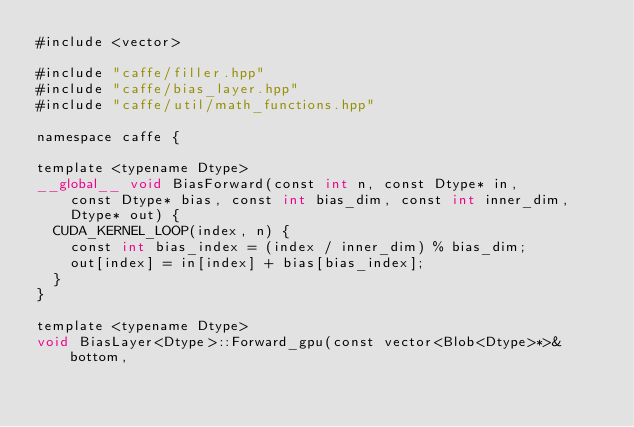<code> <loc_0><loc_0><loc_500><loc_500><_Cuda_>#include <vector>

#include "caffe/filler.hpp"
#include "caffe/bias_layer.hpp"
#include "caffe/util/math_functions.hpp"

namespace caffe {

template <typename Dtype>
__global__ void BiasForward(const int n, const Dtype* in,
    const Dtype* bias, const int bias_dim, const int inner_dim,
    Dtype* out) {
  CUDA_KERNEL_LOOP(index, n) {
    const int bias_index = (index / inner_dim) % bias_dim;
    out[index] = in[index] + bias[bias_index];
  }
}

template <typename Dtype>
void BiasLayer<Dtype>::Forward_gpu(const vector<Blob<Dtype>*>& bottom,</code> 